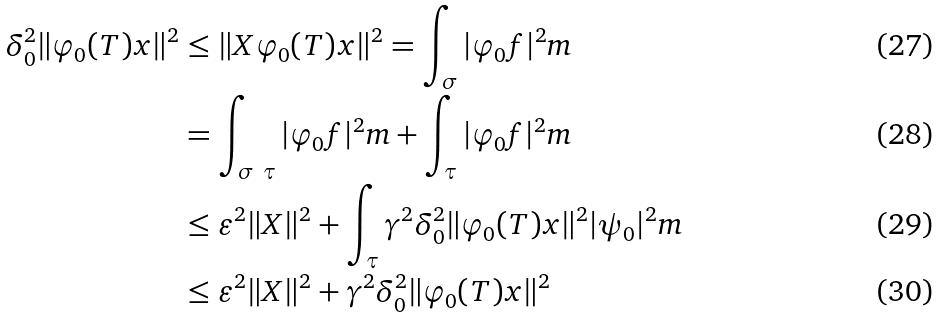Convert formula to latex. <formula><loc_0><loc_0><loc_500><loc_500>\delta _ { 0 } ^ { 2 } \| \varphi _ { 0 } ( T ) x \| ^ { 2 } & \leq \| X \varphi _ { 0 } ( T ) x \| ^ { 2 } = \int _ { \sigma } | \varphi _ { 0 } f | ^ { 2 } m \\ & = \int _ { \sigma \ \tau } | \varphi _ { 0 } f | ^ { 2 } m + \int _ { \tau } | \varphi _ { 0 } f | ^ { 2 } m \\ & \leq \varepsilon ^ { 2 } \| X \| ^ { 2 } + \int _ { \tau } \gamma ^ { 2 } \delta _ { 0 } ^ { 2 } \| \varphi _ { 0 } ( T ) x \| ^ { 2 } | \psi _ { 0 } | ^ { 2 } m \\ & \leq \varepsilon ^ { 2 } \| X \| ^ { 2 } + \gamma ^ { 2 } \delta _ { 0 } ^ { 2 } \| \varphi _ { 0 } ( T ) x \| ^ { 2 }</formula> 